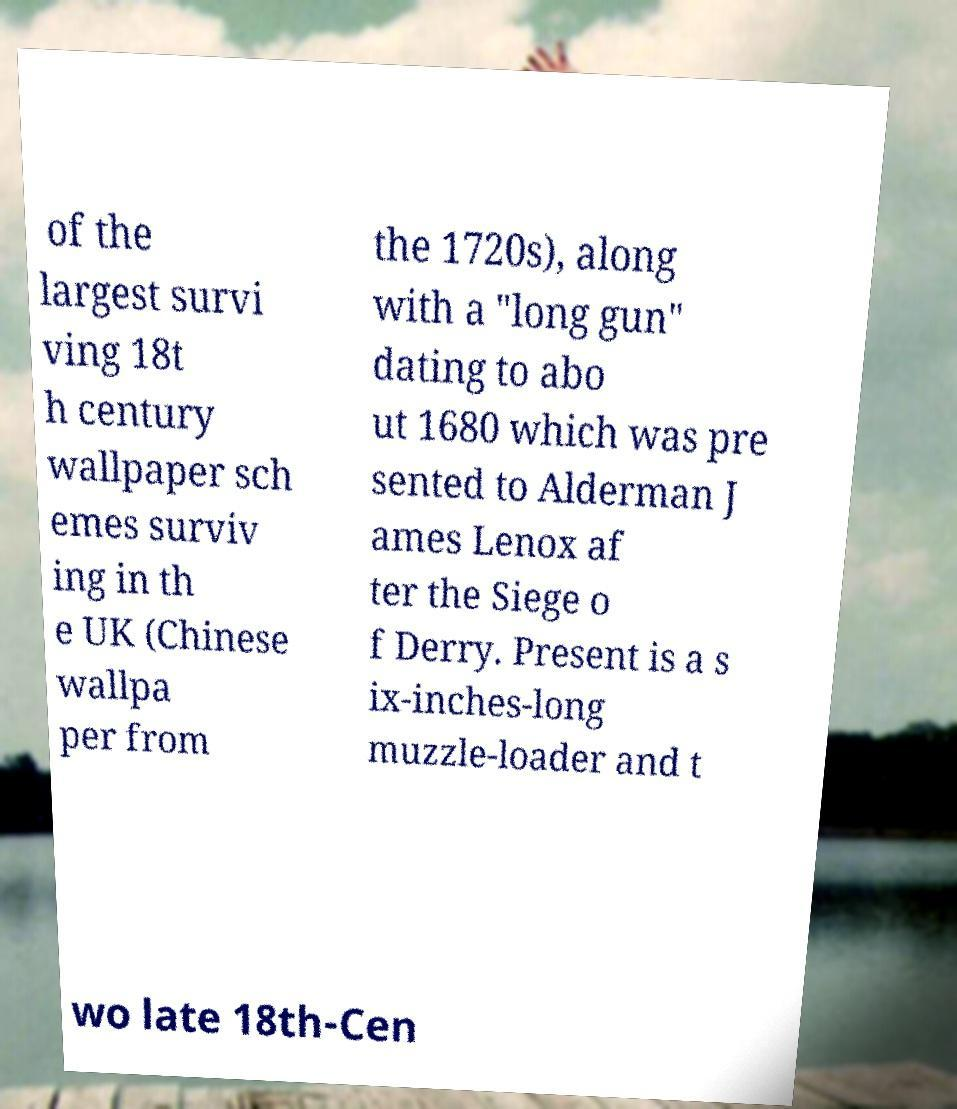For documentation purposes, I need the text within this image transcribed. Could you provide that? of the largest survi ving 18t h century wallpaper sch emes surviv ing in th e UK (Chinese wallpa per from the 1720s), along with a "long gun" dating to abo ut 1680 which was pre sented to Alderman J ames Lenox af ter the Siege o f Derry. Present is a s ix-inches-long muzzle-loader and t wo late 18th-Cen 